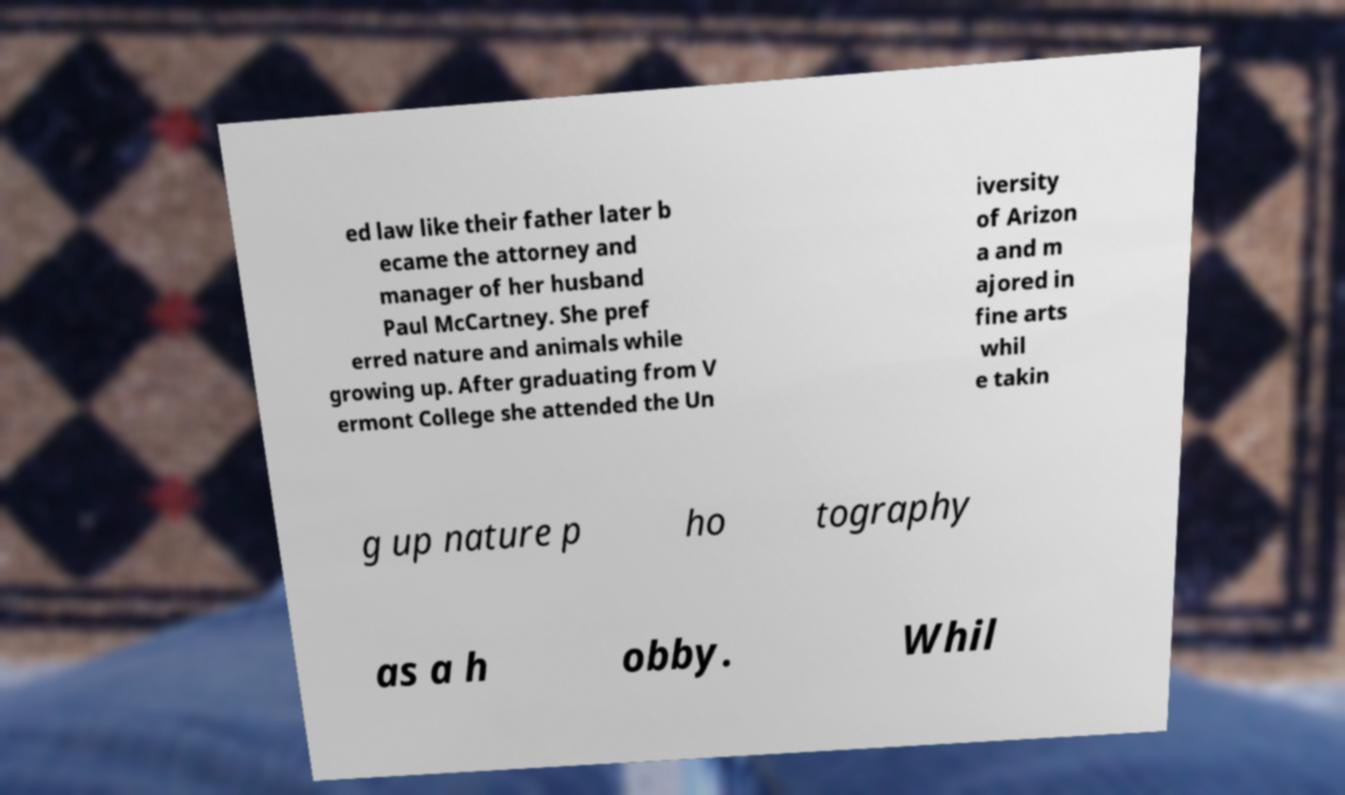Can you read and provide the text displayed in the image?This photo seems to have some interesting text. Can you extract and type it out for me? ed law like their father later b ecame the attorney and manager of her husband Paul McCartney. She pref erred nature and animals while growing up. After graduating from V ermont College she attended the Un iversity of Arizon a and m ajored in fine arts whil e takin g up nature p ho tography as a h obby. Whil 